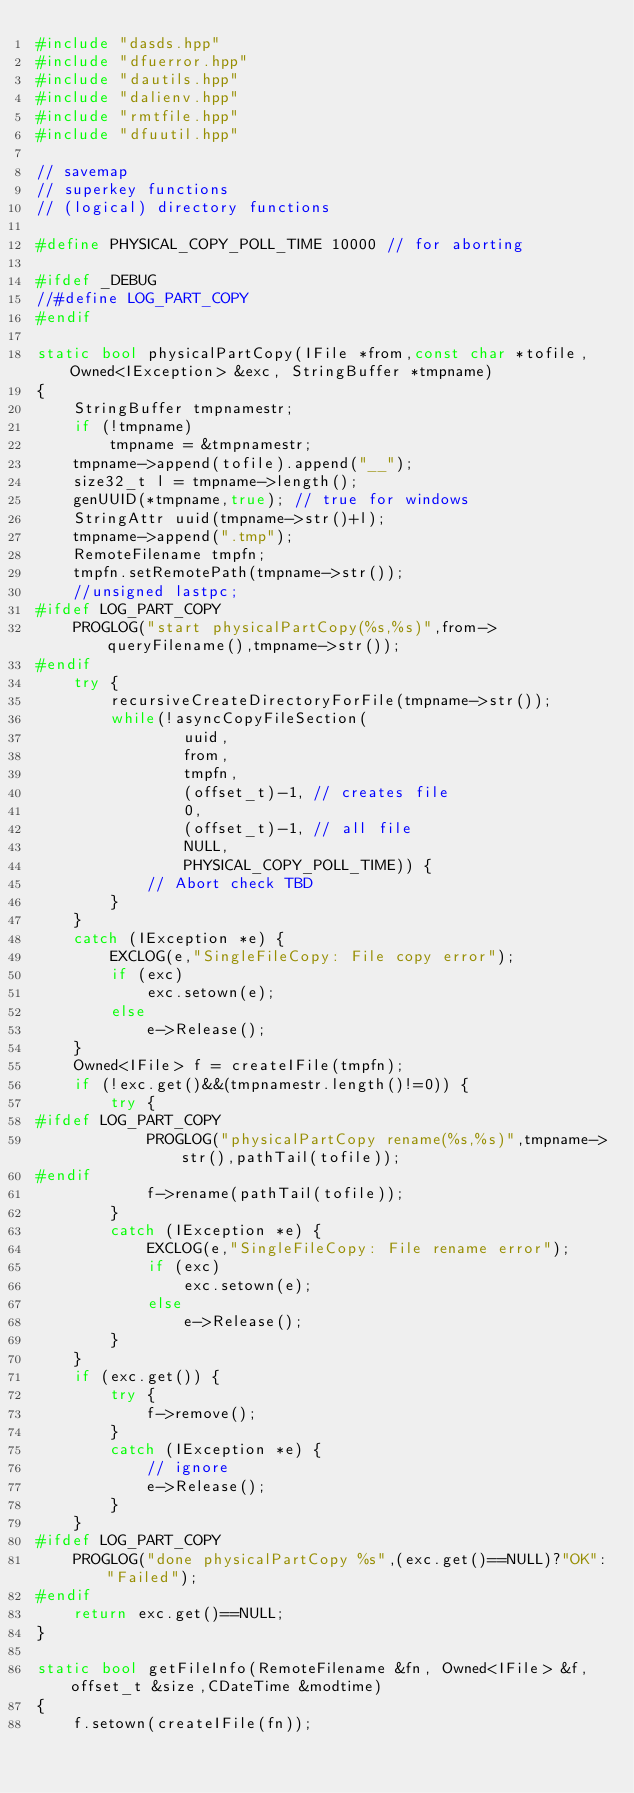<code> <loc_0><loc_0><loc_500><loc_500><_C++_>#include "dasds.hpp"
#include "dfuerror.hpp"
#include "dautils.hpp"
#include "dalienv.hpp"
#include "rmtfile.hpp"
#include "dfuutil.hpp"

// savemap
// superkey functions
// (logical) directory functions

#define PHYSICAL_COPY_POLL_TIME 10000 // for aborting

#ifdef _DEBUG
//#define LOG_PART_COPY
#endif

static bool physicalPartCopy(IFile *from,const char *tofile, Owned<IException> &exc, StringBuffer *tmpname)
{
    StringBuffer tmpnamestr;
    if (!tmpname)
        tmpname = &tmpnamestr;
    tmpname->append(tofile).append("__");
    size32_t l = tmpname->length();
    genUUID(*tmpname,true); // true for windows
    StringAttr uuid(tmpname->str()+l);
    tmpname->append(".tmp");
    RemoteFilename tmpfn;
    tmpfn.setRemotePath(tmpname->str());
    //unsigned lastpc;
#ifdef LOG_PART_COPY
    PROGLOG("start physicalPartCopy(%s,%s)",from->queryFilename(),tmpname->str());
#endif
    try {
        recursiveCreateDirectoryForFile(tmpname->str());
        while(!asyncCopyFileSection(
                uuid,
                from,
                tmpfn,
                (offset_t)-1, // creates file
                0,
                (offset_t)-1, // all file
                NULL,
                PHYSICAL_COPY_POLL_TIME)) {
            // Abort check TBD
        }
    }
    catch (IException *e) {
        EXCLOG(e,"SingleFileCopy: File copy error");
        if (exc)
            exc.setown(e);
        else
            e->Release();
    }
    Owned<IFile> f = createIFile(tmpfn);
    if (!exc.get()&&(tmpnamestr.length()!=0)) {
        try {
#ifdef LOG_PART_COPY
            PROGLOG("physicalPartCopy rename(%s,%s)",tmpname->str(),pathTail(tofile));
#endif
            f->rename(pathTail(tofile));
        }
        catch (IException *e) {
            EXCLOG(e,"SingleFileCopy: File rename error");
            if (exc)
                exc.setown(e);
            else
                e->Release();
        }
    }
    if (exc.get()) {
        try {
            f->remove();
        }
        catch (IException *e) {
            // ignore
            e->Release();
        }
    }
#ifdef LOG_PART_COPY
    PROGLOG("done physicalPartCopy %s",(exc.get()==NULL)?"OK":"Failed");
#endif
    return exc.get()==NULL;
}

static bool getFileInfo(RemoteFilename &fn, Owned<IFile> &f, offset_t &size,CDateTime &modtime)
{
    f.setown(createIFile(fn));</code> 